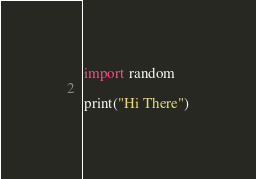<code> <loc_0><loc_0><loc_500><loc_500><_Python_>import random

print("Hi There")
</code> 